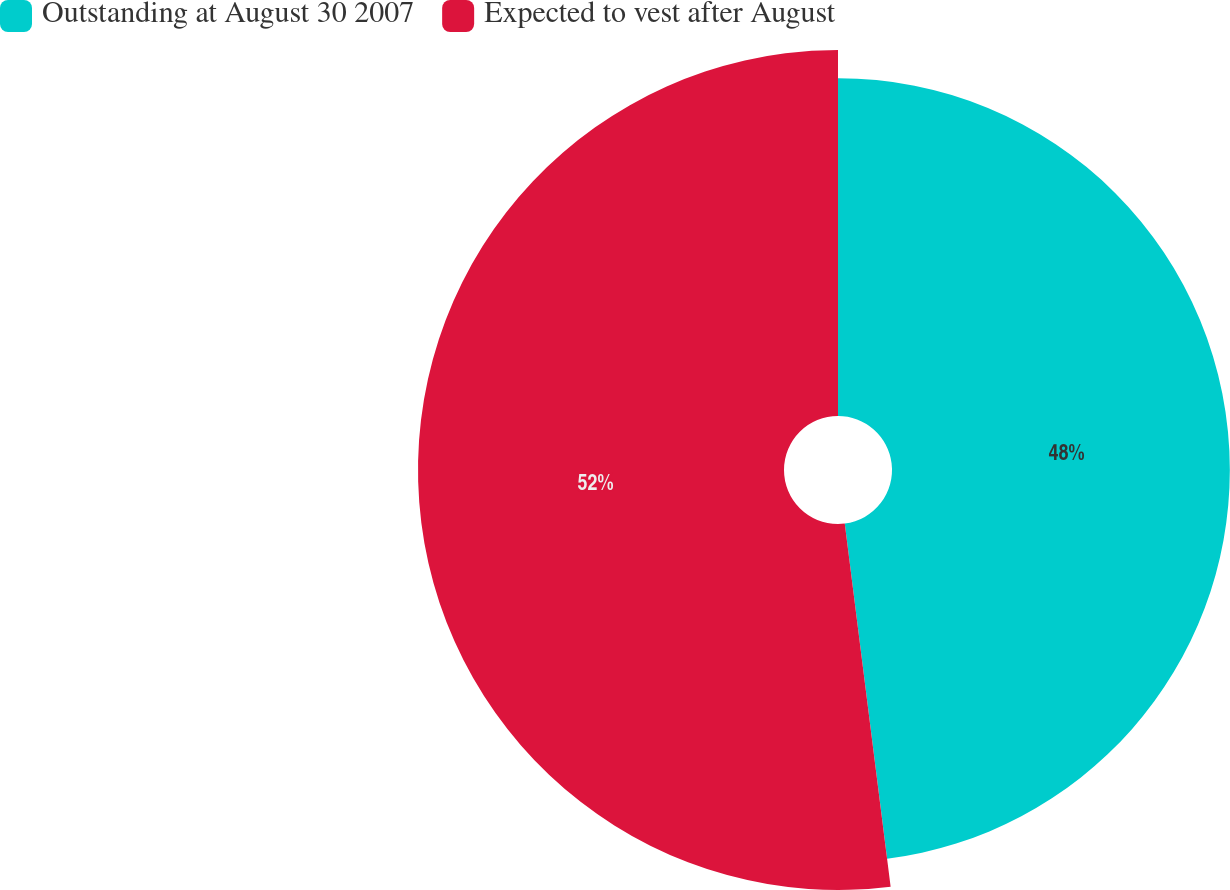Convert chart. <chart><loc_0><loc_0><loc_500><loc_500><pie_chart><fcel>Outstanding at August 30 2007<fcel>Expected to vest after August<nl><fcel>48.0%<fcel>52.0%<nl></chart> 